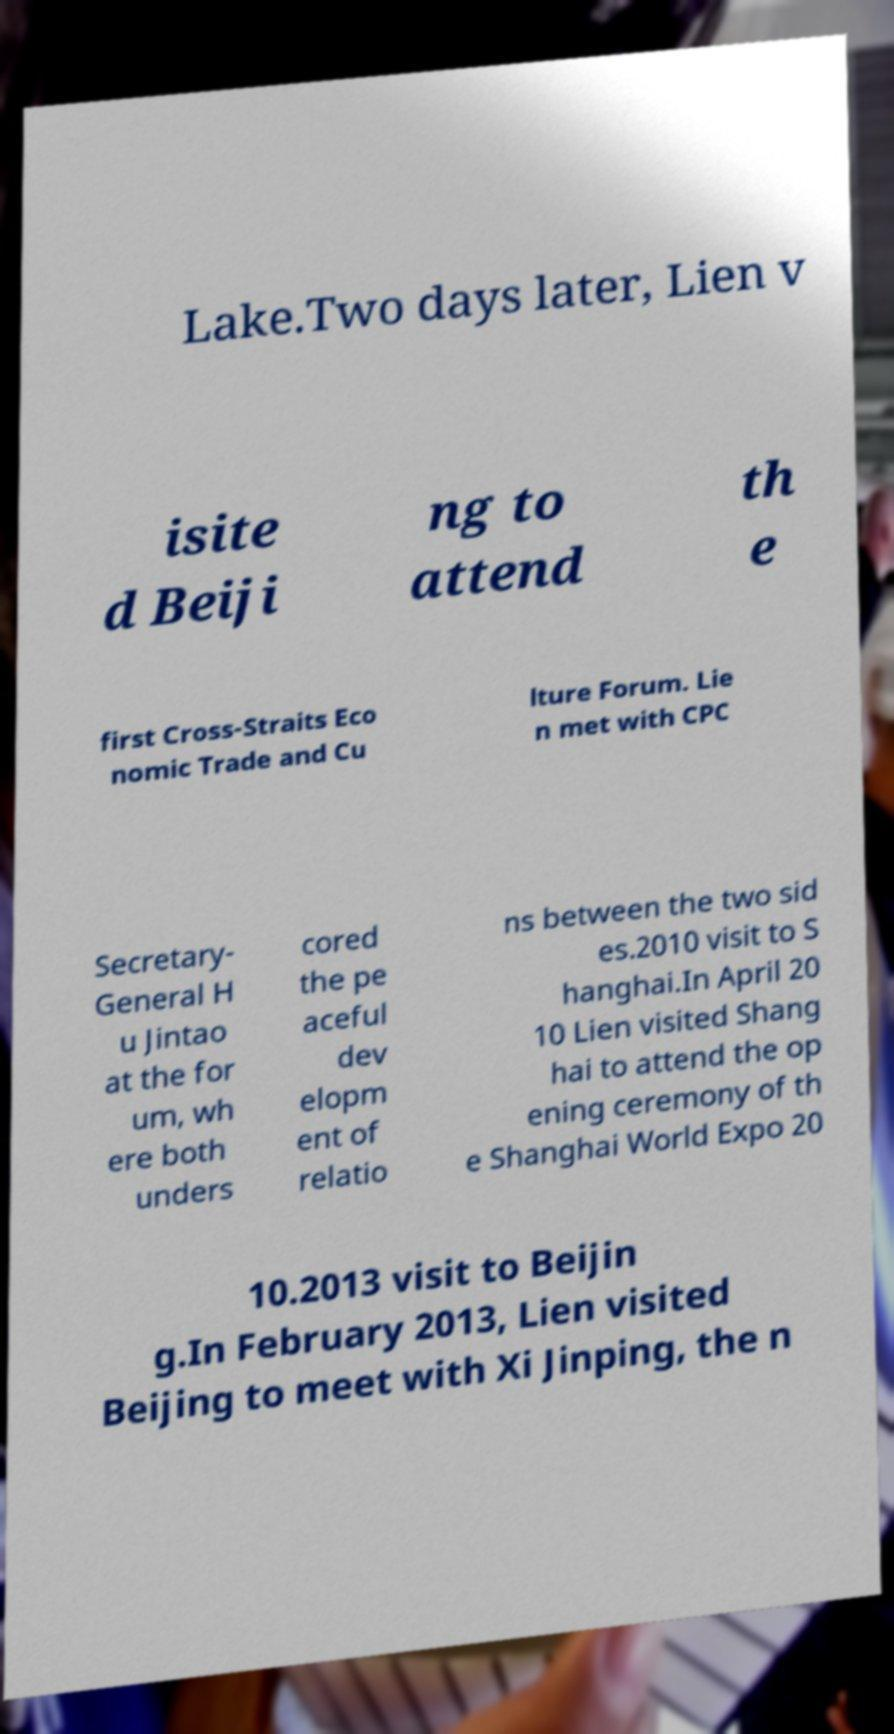Could you assist in decoding the text presented in this image and type it out clearly? Lake.Two days later, Lien v isite d Beiji ng to attend th e first Cross-Straits Eco nomic Trade and Cu lture Forum. Lie n met with CPC Secretary- General H u Jintao at the for um, wh ere both unders cored the pe aceful dev elopm ent of relatio ns between the two sid es.2010 visit to S hanghai.In April 20 10 Lien visited Shang hai to attend the op ening ceremony of th e Shanghai World Expo 20 10.2013 visit to Beijin g.In February 2013, Lien visited Beijing to meet with Xi Jinping, the n 